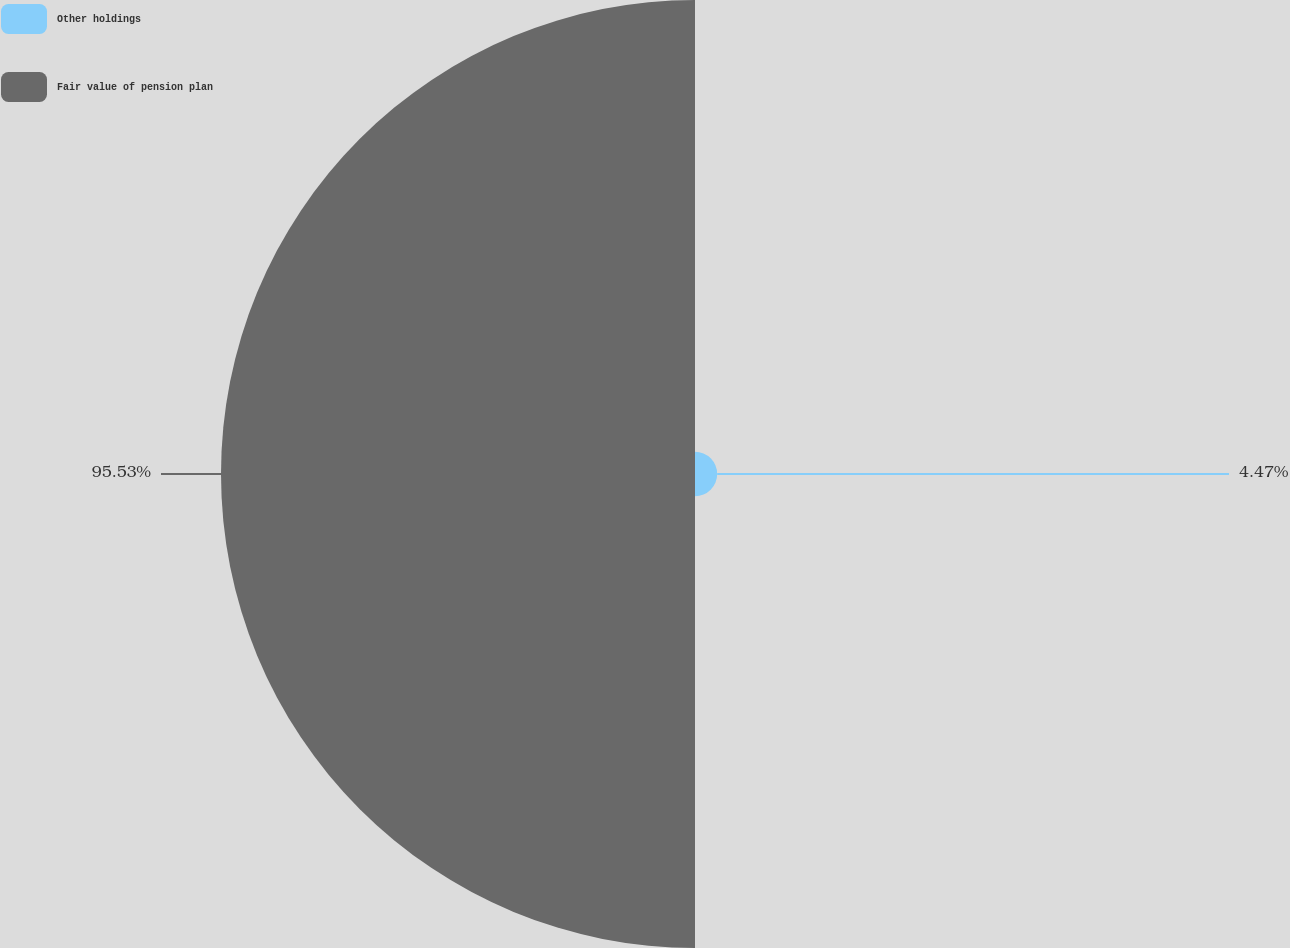Convert chart. <chart><loc_0><loc_0><loc_500><loc_500><pie_chart><fcel>Other holdings<fcel>Fair value of pension plan<nl><fcel>4.47%<fcel>95.53%<nl></chart> 